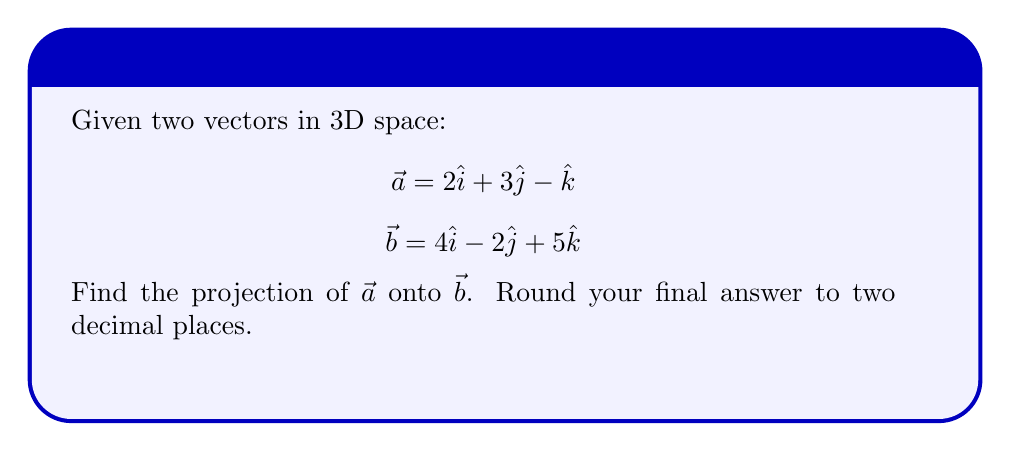Show me your answer to this math problem. To find the projection of $\vec{a}$ onto $\vec{b}$, we'll use the formula:

$$\text{proj}_{\vec{b}}\vec{a} = \frac{\vec{a} \cdot \vec{b}}{\|\vec{b}\|^2} \vec{b}$$

Let's break this down step-by-step:

1) First, calculate the dot product $\vec{a} \cdot \vec{b}$:
   $$\vec{a} \cdot \vec{b} = (2)(4) + (3)(-2) + (-1)(5) = 8 - 6 - 5 = -3$$

2) Next, calculate $\|\vec{b}\|^2$:
   $$\|\vec{b}\|^2 = 4^2 + (-2)^2 + 5^2 = 16 + 4 + 25 = 45$$

3) Now, we can calculate the scalar projection:
   $$\frac{\vec{a} \cdot \vec{b}}{\|\vec{b}\|^2} = \frac{-3}{45} = -\frac{1}{15}$$

4) Finally, multiply this scalar by $\vec{b}$ to get the vector projection:
   $$\text{proj}_{\vec{b}}\vec{a} = -\frac{1}{15}(4\hat{i} - 2\hat{j} + 5\hat{k})$$

5) Simplify:
   $$\text{proj}_{\vec{b}}\vec{a} = -\frac{4}{15}\hat{i} + \frac{2}{15}\hat{j} - \frac{1}{3}\hat{k}$$

6) Converting to decimals and rounding to two decimal places:
   $$\text{proj}_{\vec{b}}\vec{a} \approx -0.27\hat{i} + 0.13\hat{j} - 0.33\hat{k}$$
Answer: $-0.27\hat{i} + 0.13\hat{j} - 0.33\hat{k}$ 